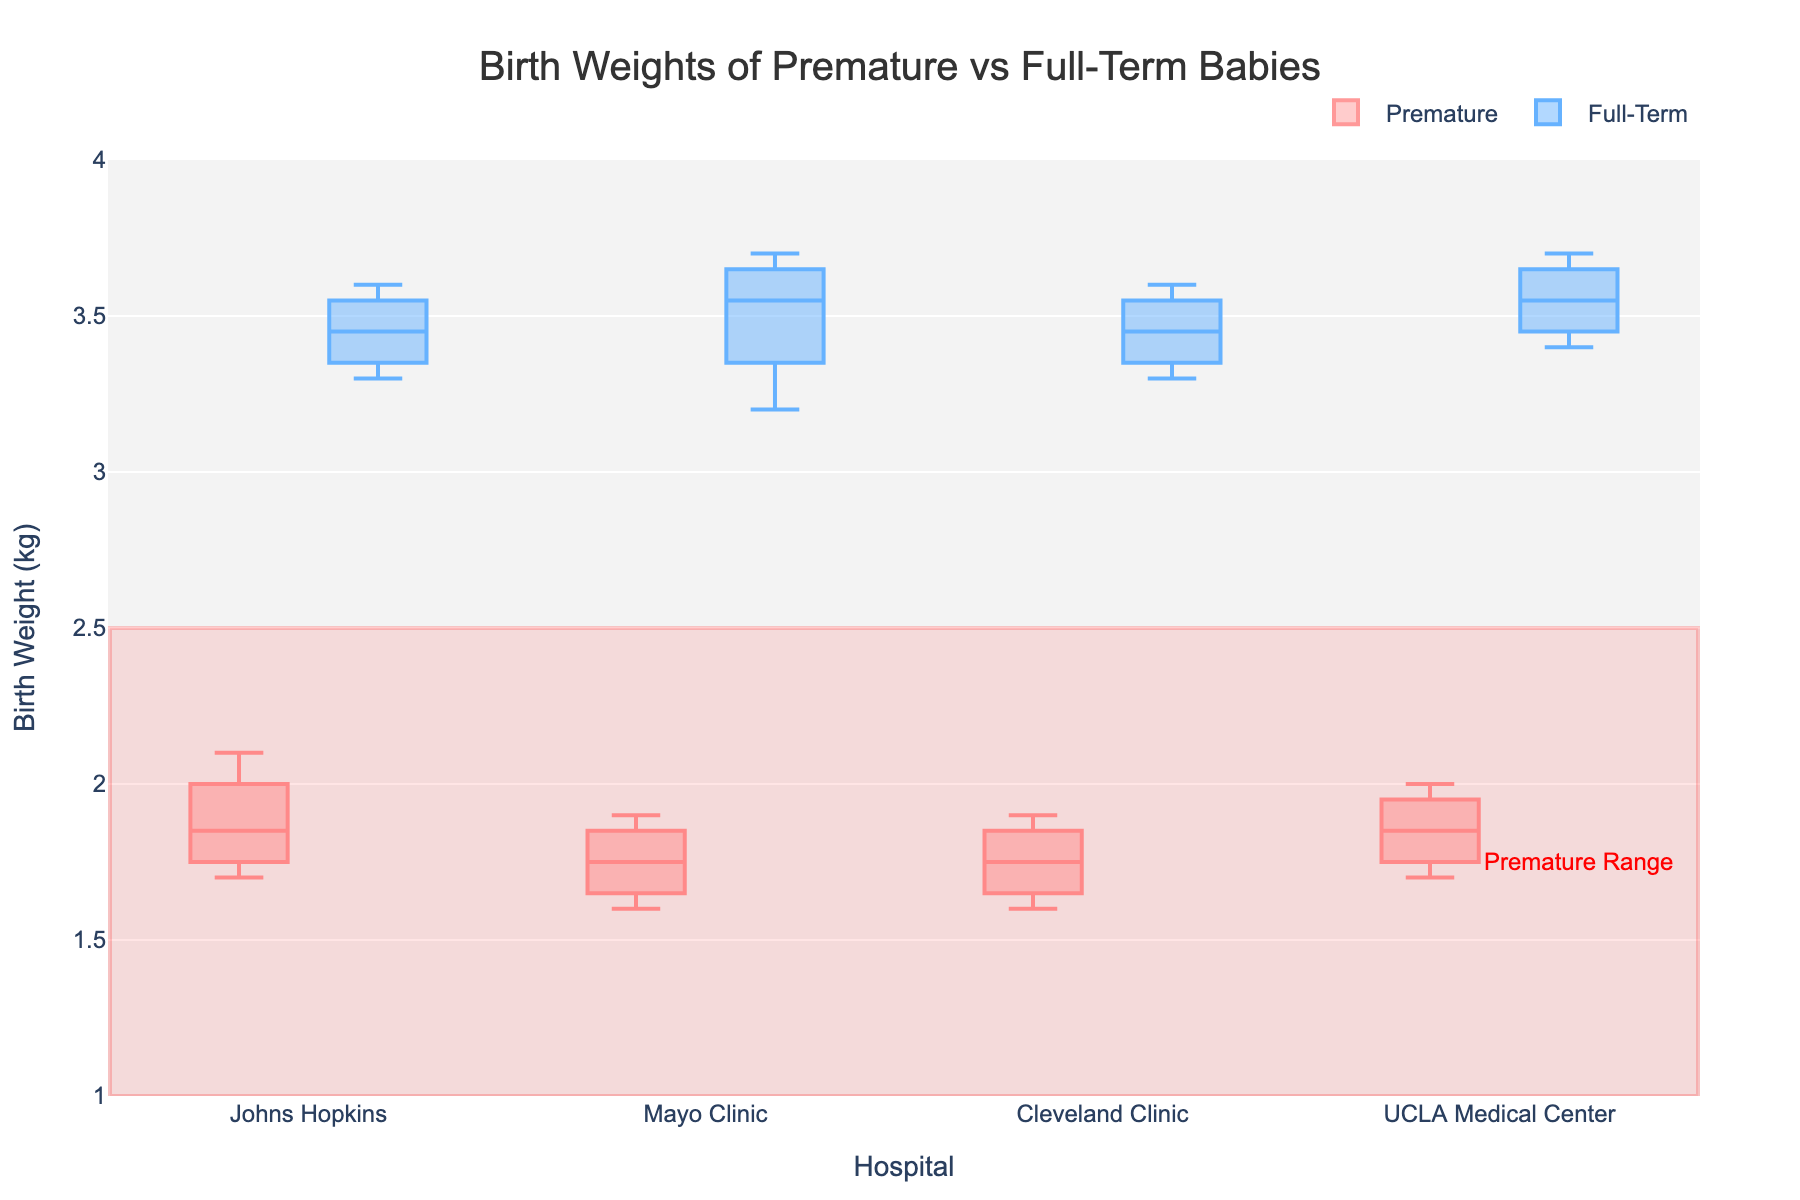What is the title of the plot? The title is usually displayed at the top of the plot and provides a summary of the information being visualized. In this case, the title reads "Birth Weights of Premature vs Full-Term Babies" at the top of the figure.
Answer: Birth Weights of Premature vs Full-Term Babies Which hospital has the lowest average birth weight for premature babies? By looking at the median lines inside the box plots for premature babies in each hospital, the box plot for Mayo Clinic appears to have the lowest median value among the premature babies.
Answer: Mayo Clinic What is the range of birth weights for full-term babies at Johns Hopkins? In a box plot, the range can be found by looking at the bottom and top of the whiskers. For full-term babies at Johns Hopkins, the range appears to be from around 3.3 kg to 3.6 kg.
Answer: 3.3 kg to 3.6 kg How do the birth weights of premature babies at UCLA Medical Center compare to those at Cleveland Clinic? By comparing the box plots for premature babies at UCLA Medical Center and Cleveland Clinic, we can see they have similar median values. However, the upper quartile for UCLA seems slightly higher than that of Cleveland Clinic, suggesting slightly higher weights on average at UCLA.
Answer: Similar median; slightly higher weights at UCLA Which group shows more variation in birth weight at Mayo Clinic, premature or full-term babies? Variation in a box plot is indicated by the length of the box and whiskers. The full-term babies at Mayo Clinic show a longer box and whiskers, meaning there is more variation in their birth weights compared to premature babies.
Answer: Full-term babies Which category has a highlighted range in the plot, and what does this range represent? There is a rectangle highlighted in the plot in the lower birth weight range, which falls between 1 kg and 2.5 kg. This range represents the birth weights for premature babies.
Answer: Premature; 1 kg to 2.5 kg What is the approximate median birth weight for full-term babies at UCLA Medical Center? The median is represented by the line inside the box. For full-term babies at UCLA Medical Center, this line appears to be slightly below 3.6 kg.
Answer: Slightly below 3.6 kg Do any hospitals show an overlap in median birth weights between premature and full-term babies? By inspecting the medians within each hospital's box plots, no overlap in medians exists; the lowest median for full-term babies is still higher than the highest median for premature babies.
Answer: No 